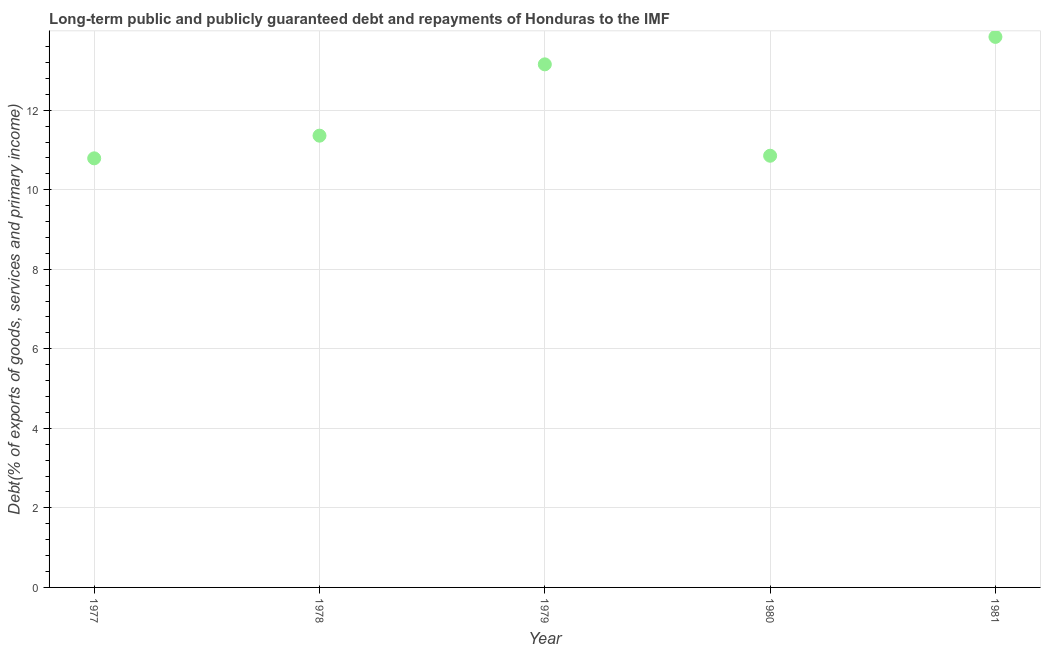What is the debt service in 1981?
Ensure brevity in your answer.  13.84. Across all years, what is the maximum debt service?
Keep it short and to the point. 13.84. Across all years, what is the minimum debt service?
Provide a short and direct response. 10.79. In which year was the debt service maximum?
Your answer should be compact. 1981. In which year was the debt service minimum?
Make the answer very short. 1977. What is the sum of the debt service?
Provide a succinct answer. 60. What is the difference between the debt service in 1978 and 1981?
Make the answer very short. -2.48. What is the average debt service per year?
Your answer should be compact. 12. What is the median debt service?
Make the answer very short. 11.36. In how many years, is the debt service greater than 4 %?
Offer a very short reply. 5. What is the ratio of the debt service in 1977 to that in 1980?
Your response must be concise. 0.99. Is the debt service in 1978 less than that in 1979?
Provide a succinct answer. Yes. What is the difference between the highest and the second highest debt service?
Provide a short and direct response. 0.69. What is the difference between the highest and the lowest debt service?
Offer a terse response. 3.05. Does the debt service monotonically increase over the years?
Provide a short and direct response. No. How many dotlines are there?
Your answer should be very brief. 1. How many years are there in the graph?
Offer a terse response. 5. What is the difference between two consecutive major ticks on the Y-axis?
Give a very brief answer. 2. Are the values on the major ticks of Y-axis written in scientific E-notation?
Offer a very short reply. No. Does the graph contain any zero values?
Provide a short and direct response. No. What is the title of the graph?
Provide a succinct answer. Long-term public and publicly guaranteed debt and repayments of Honduras to the IMF. What is the label or title of the Y-axis?
Make the answer very short. Debt(% of exports of goods, services and primary income). What is the Debt(% of exports of goods, services and primary income) in 1977?
Your answer should be compact. 10.79. What is the Debt(% of exports of goods, services and primary income) in 1978?
Your answer should be very brief. 11.36. What is the Debt(% of exports of goods, services and primary income) in 1979?
Provide a succinct answer. 13.15. What is the Debt(% of exports of goods, services and primary income) in 1980?
Keep it short and to the point. 10.86. What is the Debt(% of exports of goods, services and primary income) in 1981?
Offer a terse response. 13.84. What is the difference between the Debt(% of exports of goods, services and primary income) in 1977 and 1978?
Your answer should be very brief. -0.57. What is the difference between the Debt(% of exports of goods, services and primary income) in 1977 and 1979?
Keep it short and to the point. -2.36. What is the difference between the Debt(% of exports of goods, services and primary income) in 1977 and 1980?
Provide a short and direct response. -0.07. What is the difference between the Debt(% of exports of goods, services and primary income) in 1977 and 1981?
Provide a short and direct response. -3.05. What is the difference between the Debt(% of exports of goods, services and primary income) in 1978 and 1979?
Offer a very short reply. -1.79. What is the difference between the Debt(% of exports of goods, services and primary income) in 1978 and 1980?
Keep it short and to the point. 0.5. What is the difference between the Debt(% of exports of goods, services and primary income) in 1978 and 1981?
Give a very brief answer. -2.48. What is the difference between the Debt(% of exports of goods, services and primary income) in 1979 and 1980?
Offer a very short reply. 2.3. What is the difference between the Debt(% of exports of goods, services and primary income) in 1979 and 1981?
Your response must be concise. -0.69. What is the difference between the Debt(% of exports of goods, services and primary income) in 1980 and 1981?
Give a very brief answer. -2.99. What is the ratio of the Debt(% of exports of goods, services and primary income) in 1977 to that in 1979?
Make the answer very short. 0.82. What is the ratio of the Debt(% of exports of goods, services and primary income) in 1977 to that in 1980?
Offer a terse response. 0.99. What is the ratio of the Debt(% of exports of goods, services and primary income) in 1977 to that in 1981?
Keep it short and to the point. 0.78. What is the ratio of the Debt(% of exports of goods, services and primary income) in 1978 to that in 1979?
Your answer should be very brief. 0.86. What is the ratio of the Debt(% of exports of goods, services and primary income) in 1978 to that in 1980?
Your response must be concise. 1.05. What is the ratio of the Debt(% of exports of goods, services and primary income) in 1978 to that in 1981?
Your answer should be compact. 0.82. What is the ratio of the Debt(% of exports of goods, services and primary income) in 1979 to that in 1980?
Ensure brevity in your answer.  1.21. What is the ratio of the Debt(% of exports of goods, services and primary income) in 1980 to that in 1981?
Ensure brevity in your answer.  0.78. 